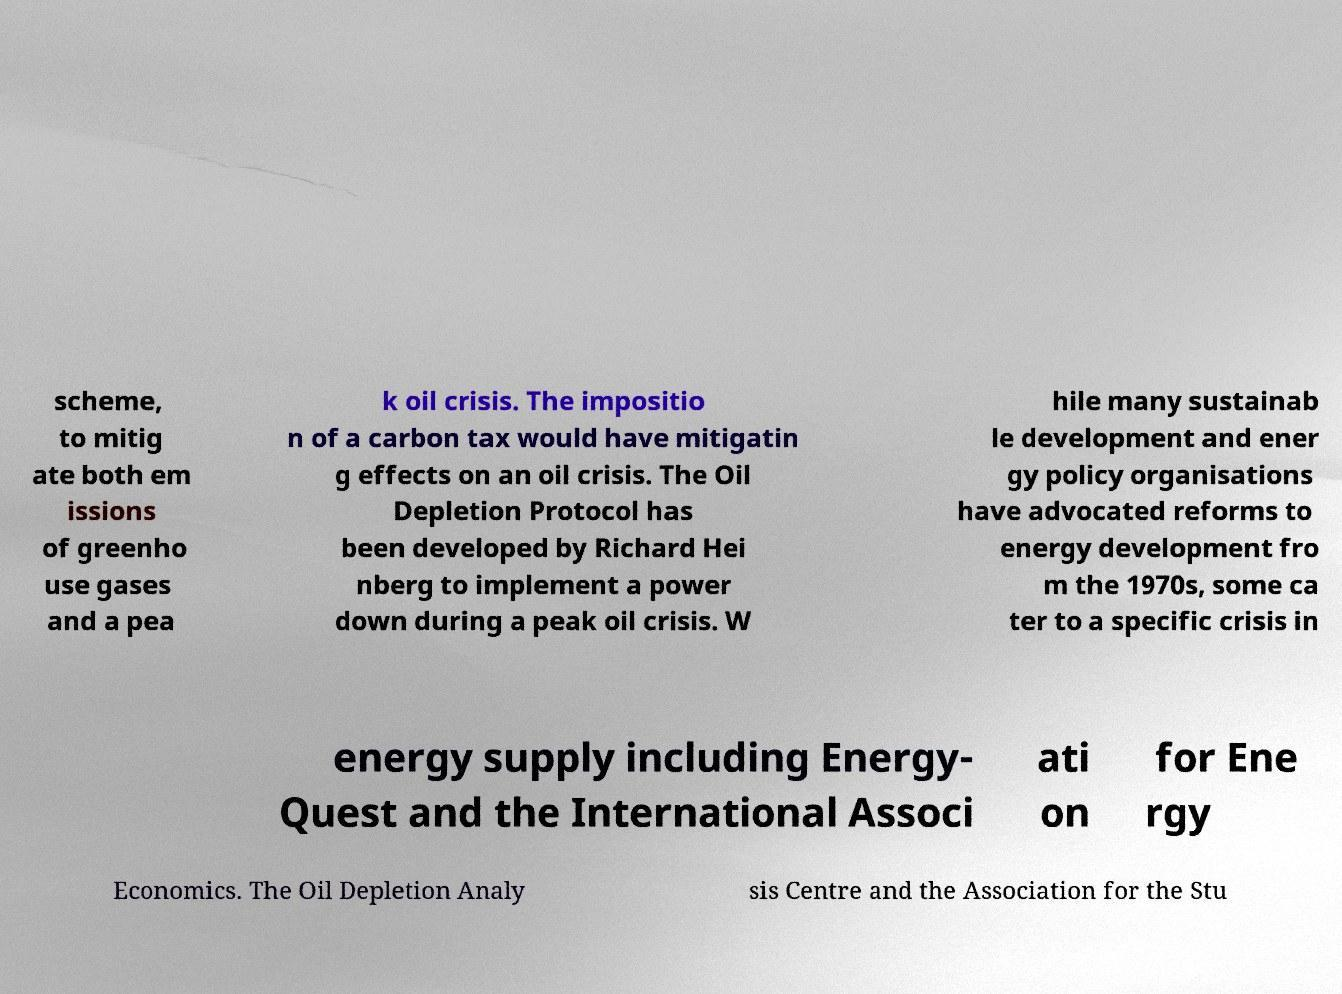Can you accurately transcribe the text from the provided image for me? scheme, to mitig ate both em issions of greenho use gases and a pea k oil crisis. The impositio n of a carbon tax would have mitigatin g effects on an oil crisis. The Oil Depletion Protocol has been developed by Richard Hei nberg to implement a power down during a peak oil crisis. W hile many sustainab le development and ener gy policy organisations have advocated reforms to energy development fro m the 1970s, some ca ter to a specific crisis in energy supply including Energy- Quest and the International Associ ati on for Ene rgy Economics. The Oil Depletion Analy sis Centre and the Association for the Stu 